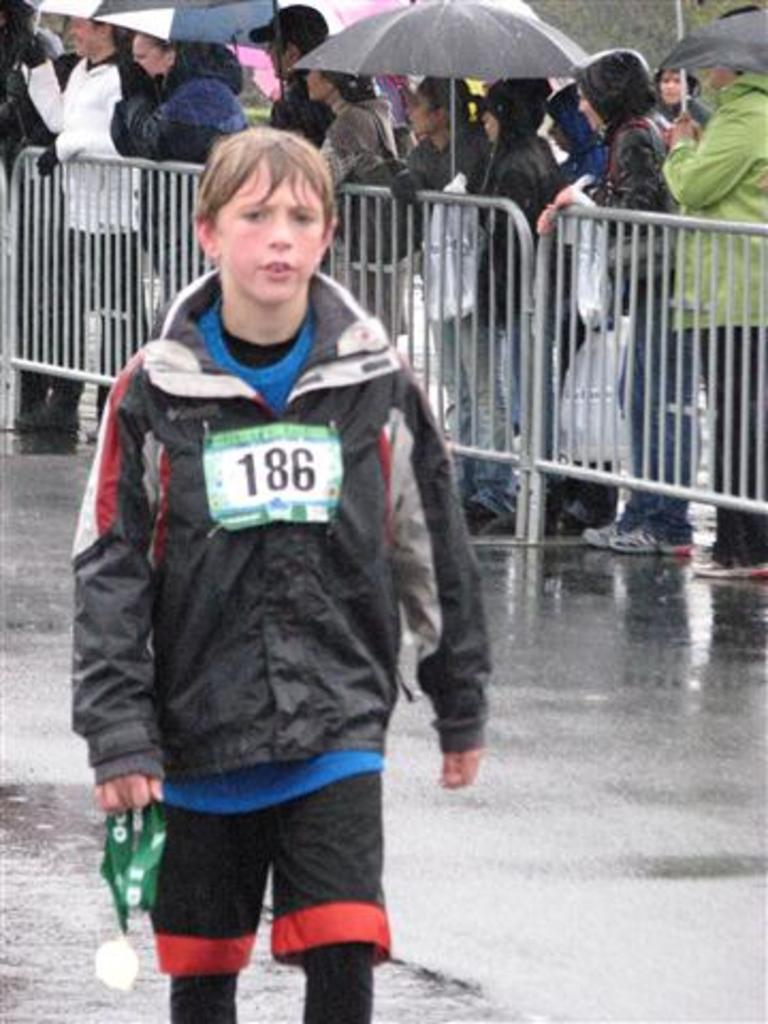What is the person in the image doing? The person in the image is walking on the road. What is the person holding while walking? The person is holding a tag. What is the weather like in the image? It is raining in the image. What can be seen in the background of the image? There is a fence in the image. What are the people near the fence doing? People are standing in a queue near the fence. What are the people holding to protect themselves from the rain? The people are holding umbrellas. What type of pet is the person walking in the image? There is no pet present in the image; the person is walking alone. What class is the person attending in the image? There is no indication of a class or educational setting in the image. 